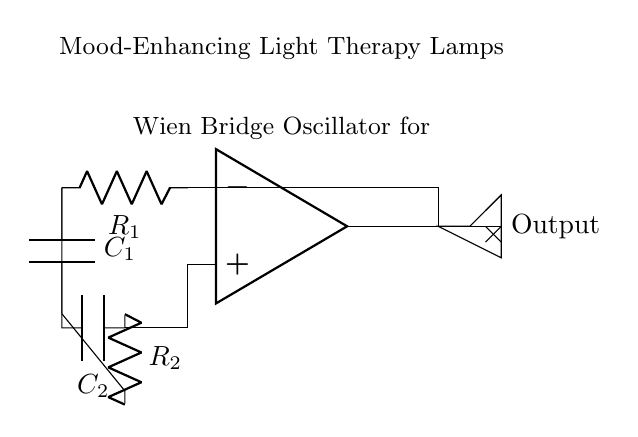What type of oscillator is depicted in the circuit? The circuit consists of a Wien Bridge Oscillator, identifiable from the op-amp configuration and feedback elements.
Answer: Wien Bridge What components are used for feedback in this oscillator? The feedback in this oscillator is provided by resistors and capacitors, specifically R1, R2, C1, and C2, which create a balance necessary for oscillation.
Answer: R1, R2, C1, C2 What is the role of the op-amp in the circuit? The op-amp amplifies the voltage signal and maintains oscillation through the feedback network, central to the operation of the oscillator.
Answer: Amplifier Which component generates the output for the light therapy lamp? The output signal for the lamp is generated from the output of the op-amp, which is connected to the lamp component that represents the light therapy.
Answer: Op-amp output What determines the frequency of oscillation in this circuit? The frequency of oscillation is determined by the values of the capacitors and resistors used in the feedback network, specifically R1, R2, C1, and C2.
Answer: R1, R2, C1, C2 How does the feedback influence the stability of oscillation? Feedback is crucial for the stability; it regulates the gain of the op-amp to ensure continual oscillation without saturation or attenuation, helping maintain balance.
Answer: Stability balance Does this circuit require additional components for brightness control? While the schematic does not show brightness control components, typically a variable resistor or a potentiometer could be added for brightness adjustment in practical applications.
Answer: No (not shown) 